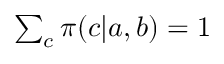<formula> <loc_0><loc_0><loc_500><loc_500>\begin{array} { r } { \sum _ { c } \pi ( c | a , b ) = 1 } \end{array}</formula> 